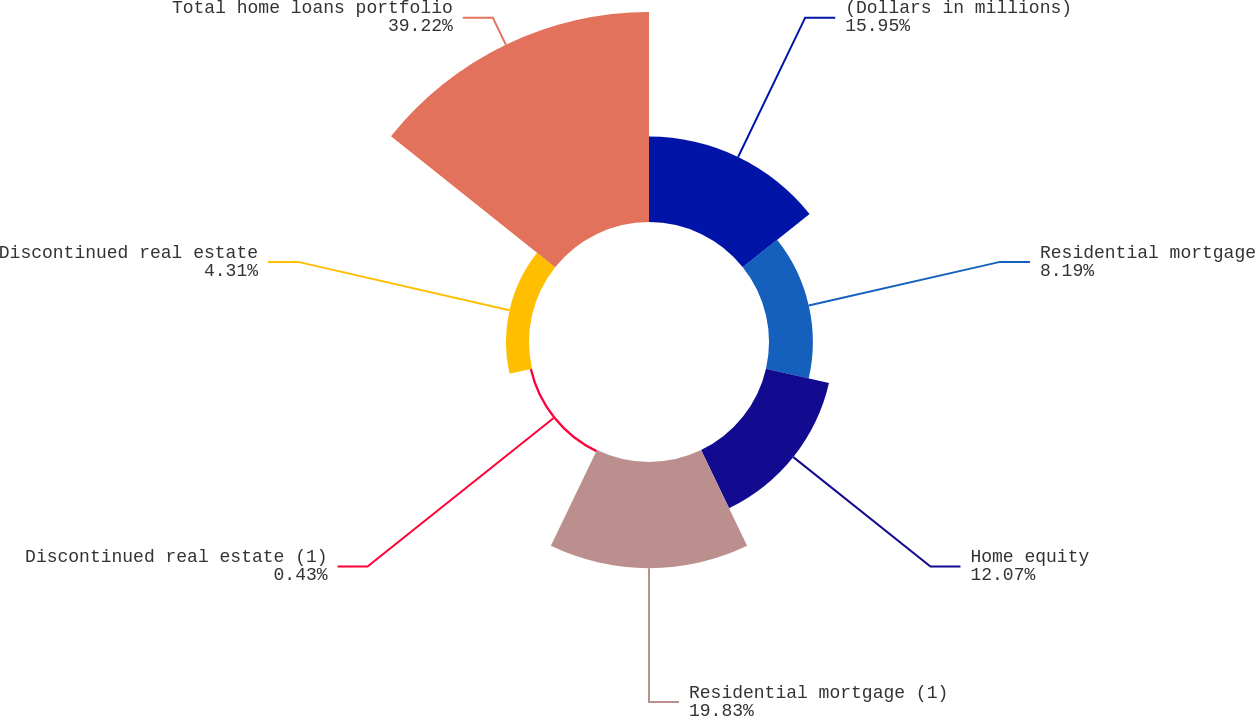Convert chart. <chart><loc_0><loc_0><loc_500><loc_500><pie_chart><fcel>(Dollars in millions)<fcel>Residential mortgage<fcel>Home equity<fcel>Residential mortgage (1)<fcel>Discontinued real estate (1)<fcel>Discontinued real estate<fcel>Total home loans portfolio<nl><fcel>15.95%<fcel>8.19%<fcel>12.07%<fcel>19.83%<fcel>0.43%<fcel>4.31%<fcel>39.23%<nl></chart> 